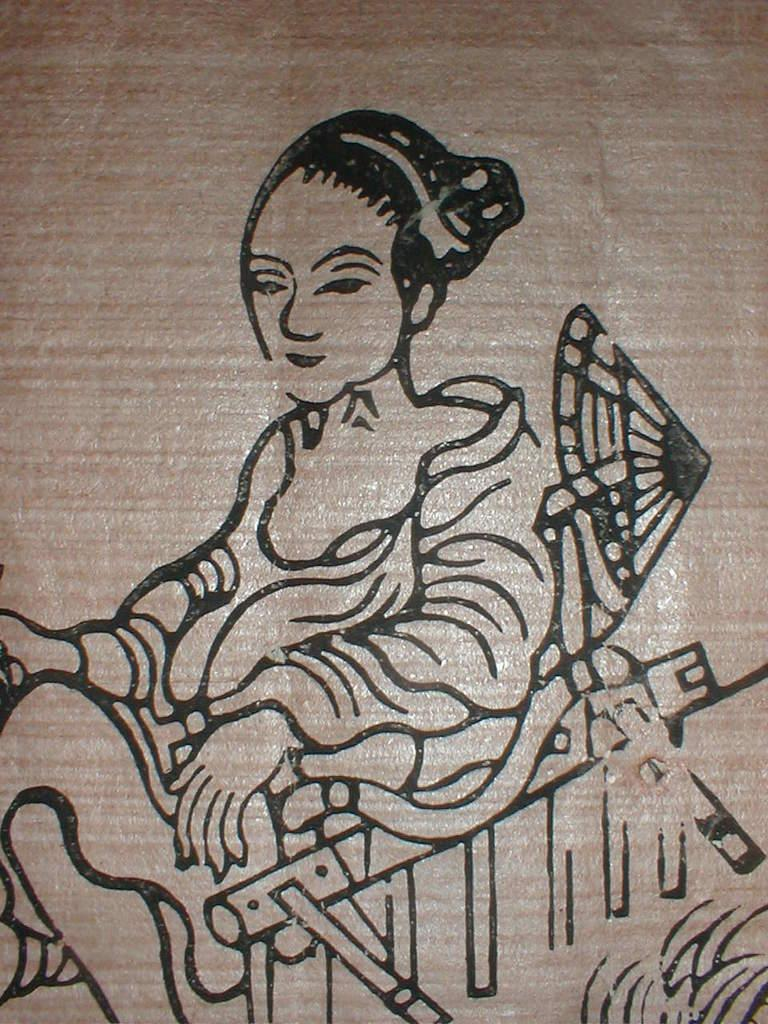What is the main subject of the image? There is a piece of art in the image. What is depicted in the art? The art features persons. What is the color of the surface on which the art is placed? The art is on a brown color surface. Can you see any visitors interacting with the persons in the art? There are no visitors present in the image, as it only features the piece of art. Are there any swings visible in the image? There are no swings present in the image. 